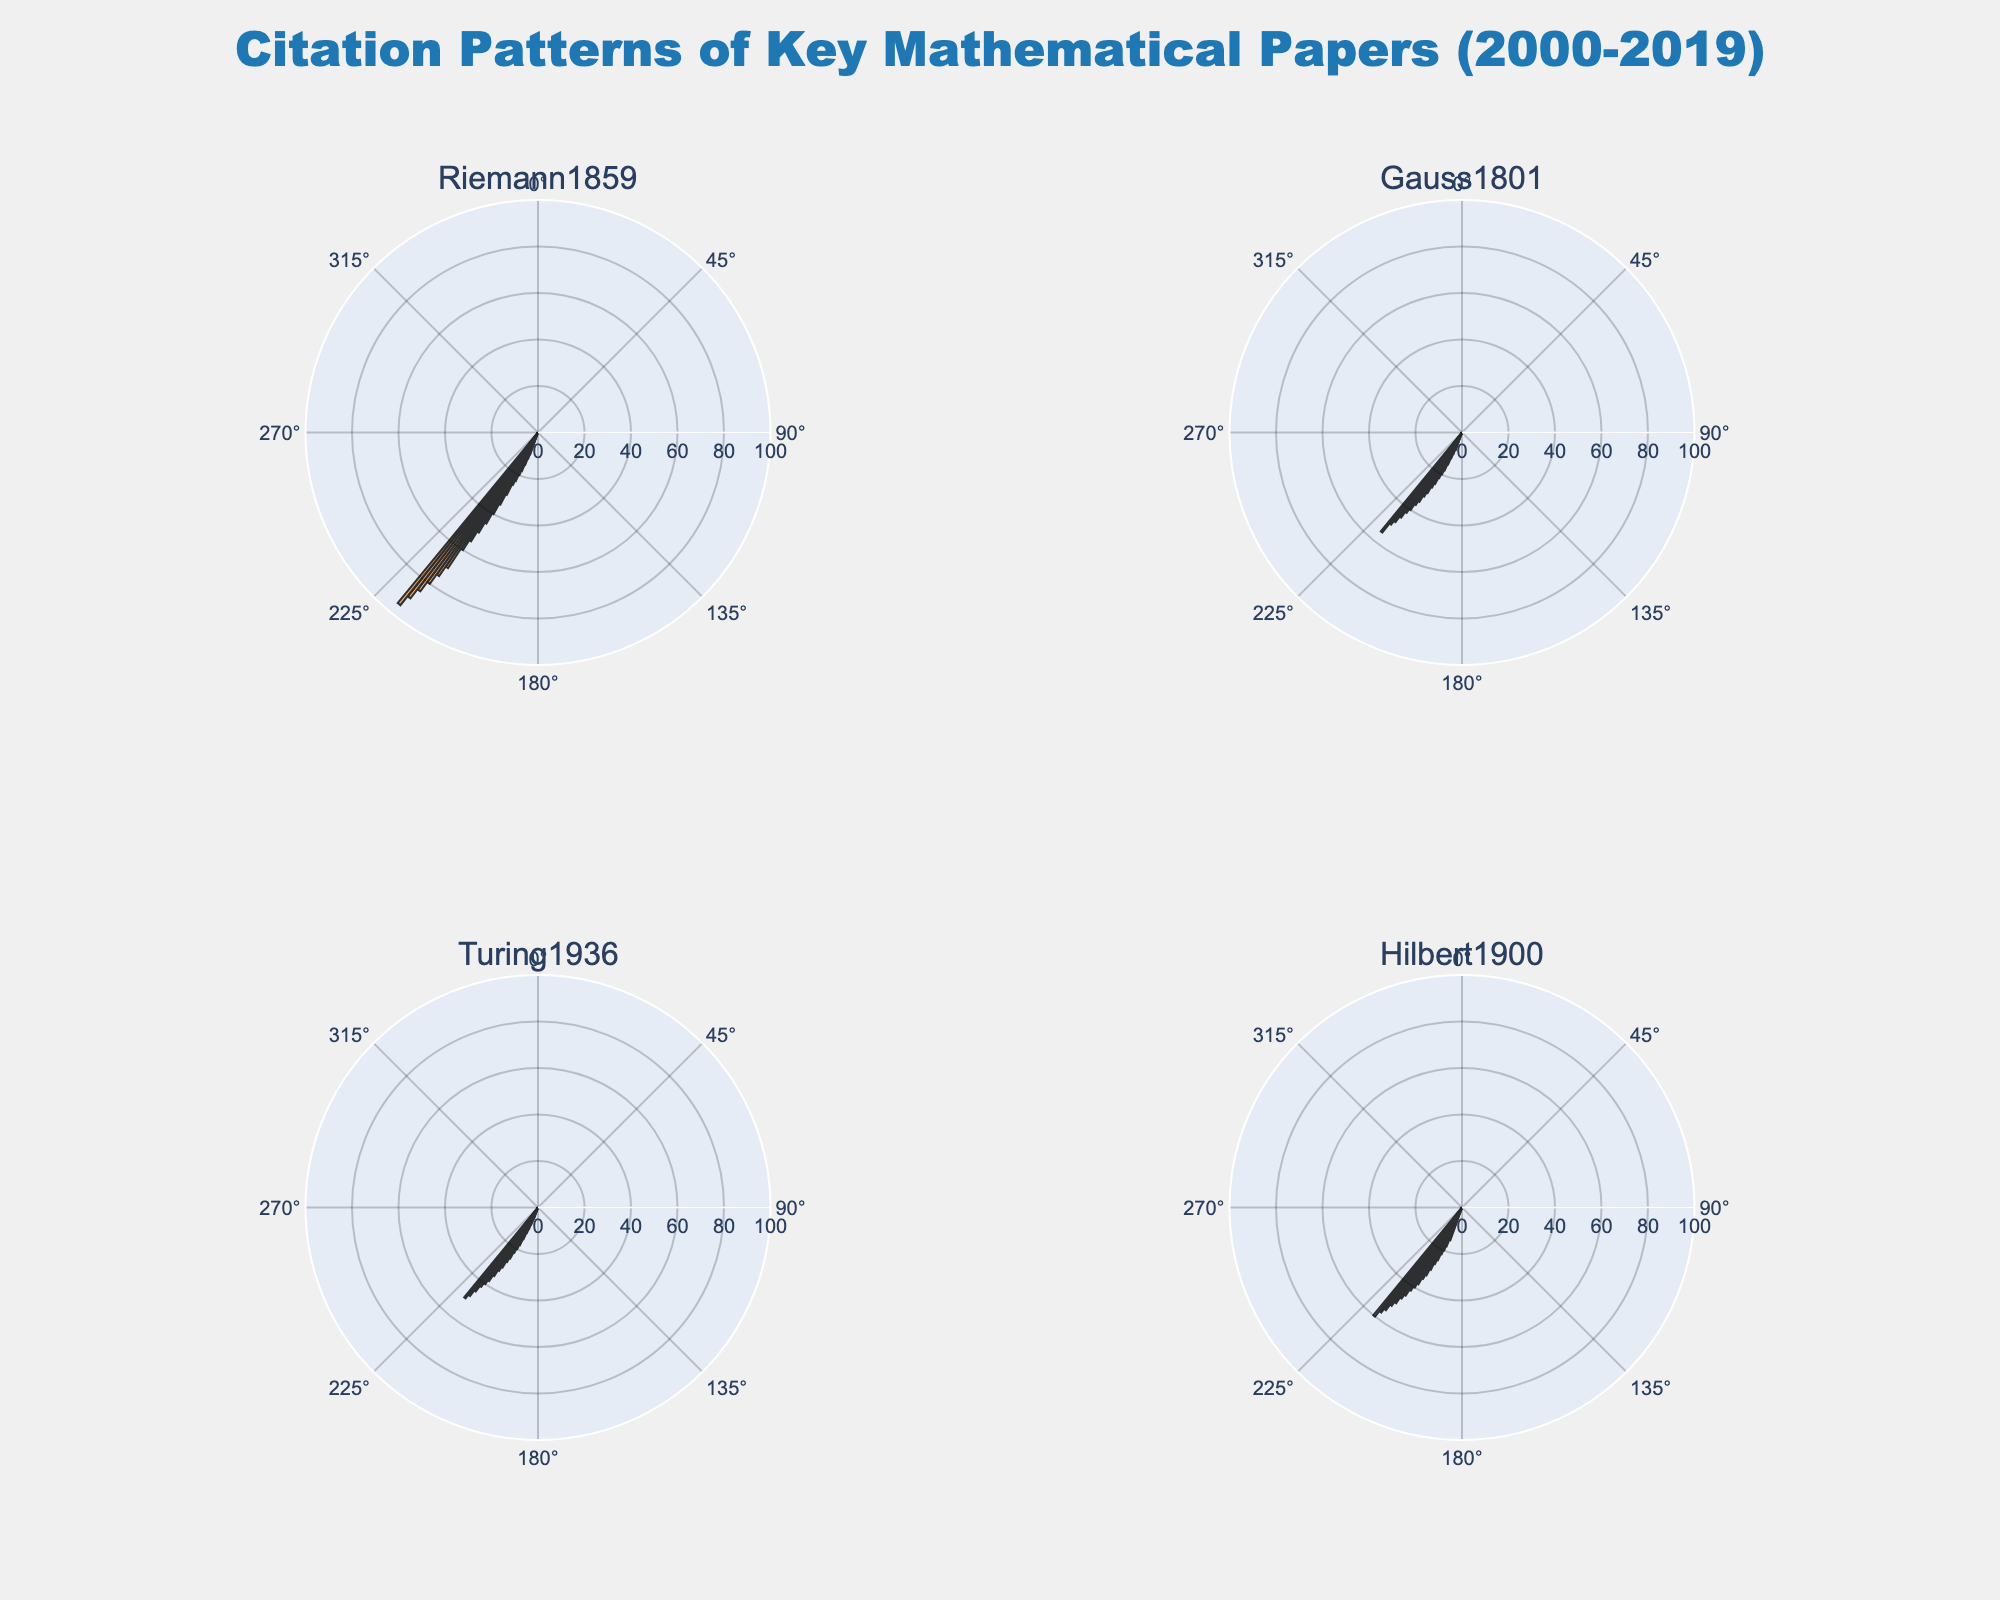What are the titles of the subplots? The titles of the subplots are the names of the papers being analyzed. There are four titles shown, which are 'Riemann1859', 'Gauss1801', 'Turing1936', and 'Hilbert1900'. These titles indicate the key mathematical papers being analyzed for citation patterns.
Answer: 'Riemann1859', 'Gauss1801', 'Turing1936', 'Hilbert1900' What is the overall trend in citations for the paper 'Riemann1859' over the years? The overall trend in citations for the paper 'Riemann1859' shows a continuous increase from 2000 to 2019. Starting with 10 citations in 2000, the citations increase almost linearly to 95 citations by 2019.
Answer: Increasing trend Which paper had the highest number of citations in 2019? By examining the radial lengths of the bars for the year 2019 across all subplots, it is evident that 'Riemann1859' has the highest number of citations, with a value of 95.
Answer: 'Riemann1859' Compare the citation counts for the paper 'Gauss1801' and 'Turing1936' in 2010. Which was higher? In the subplots for 'Gauss1801' and 'Turing1936', we observe the bar lengths for the year 2010. 'Gauss1801' has 30 citations, whereas 'Turing1936' has 27 citations, making 'Gauss1801' higher in 2010.
Answer: 'Gauss1801' How did the citation count for the paper 'Hilbert1900' change from 2005 to 2010? In the subplot for 'Hilbert1900', the citation counts increased from 25 in 2005 to 38 in 2010. The difference is 38 - 25 = 13 citations. Thus, the citation count increased by 13 over these five years.
Answer: Increased by 13 What is the median citation count for 'Turing1936' across the 20-year period shown? To calculate the median, the citation counts from 2000 to 2019 need to be ordered. For 'Turing1936', these counts are: 5, 5, 8, 10, 12, 15, 18, 20, 22, 25, 27, 30, 32, 35, 38, 40, 42, 45, 48, 50. The middle values (10th and 11th) are 25 and 27. The median is (25 + 27) / 2 = 26.
Answer: 26 Which paper shows the most consistent increase in citations over the given period? By observing the subplots, 'Riemann1859' shows the most consistent increase without any fluctuations in the trend. The increments each year are nearly uniform compared to the other papers.
Answer: 'Riemann1859' In which year does the paper 'Gauss1801' show the largest single-year increase in citations? For 'Gauss1801', the citation count increases need to be checked year by year. The biggest jump in a single year is from 2008 (25 citations) to 2009 (27 citations), a difference of 2. No larger increment is observed.
Answer: 2008 to 2009 What is the range of citation counts for 'Hilbert1900' over the 20-year span? The range of citation counts is derived from the difference between the maximum and minimum citation counts for 'Hilbert1900'. The maximum citation count is 60 (in 2019), and the minimum is 15 (in 2000). The range is 60 - 15 = 45.
Answer: 45 